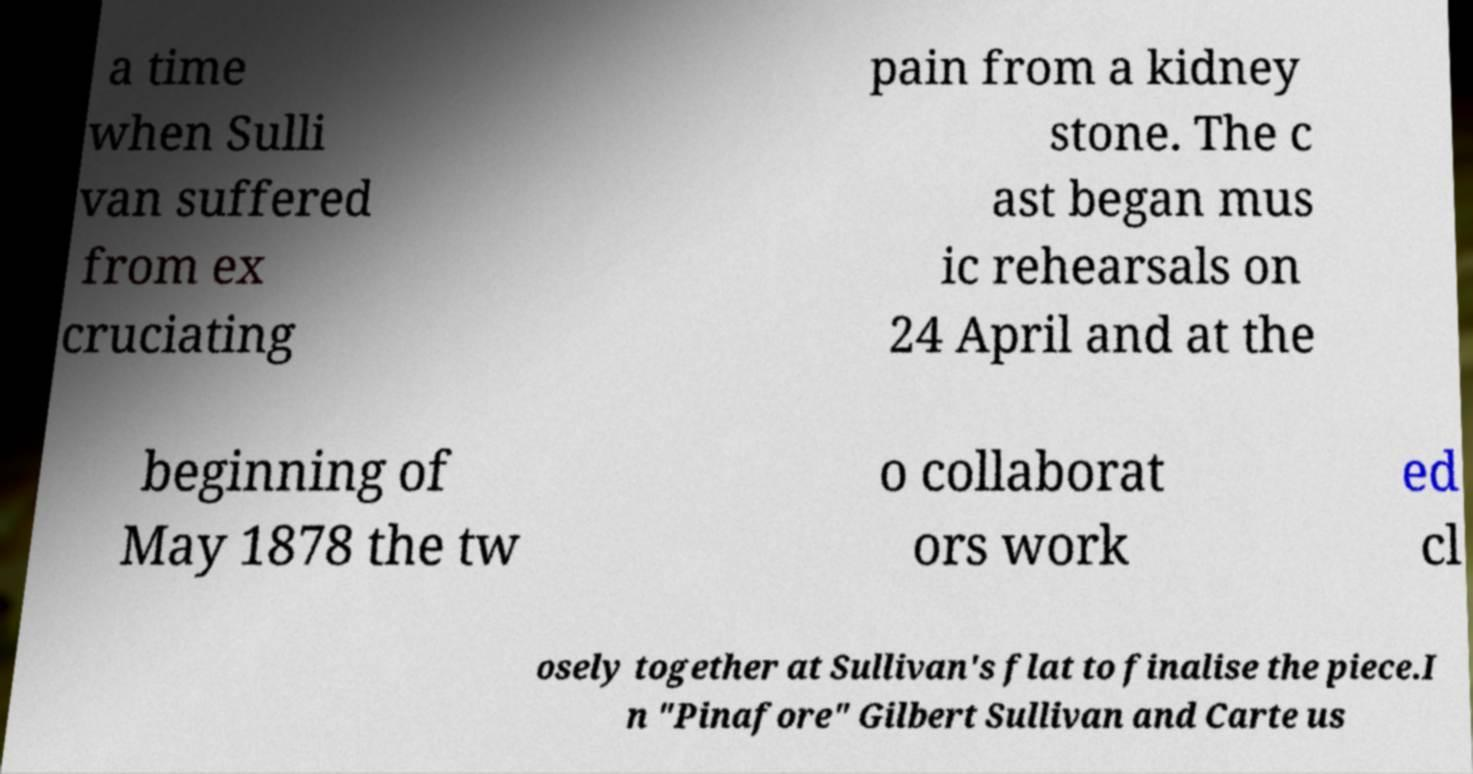I need the written content from this picture converted into text. Can you do that? a time when Sulli van suffered from ex cruciating pain from a kidney stone. The c ast began mus ic rehearsals on 24 April and at the beginning of May 1878 the tw o collaborat ors work ed cl osely together at Sullivan's flat to finalise the piece.I n "Pinafore" Gilbert Sullivan and Carte us 